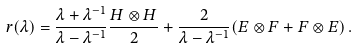<formula> <loc_0><loc_0><loc_500><loc_500>r ( \lambda ) = \frac { \lambda + \lambda ^ { - 1 } } { \lambda - \lambda ^ { - 1 } } \frac { H \otimes H } { 2 } + \frac { 2 } { \lambda - \lambda ^ { - 1 } } ( E \otimes F + F \otimes E ) \, .</formula> 